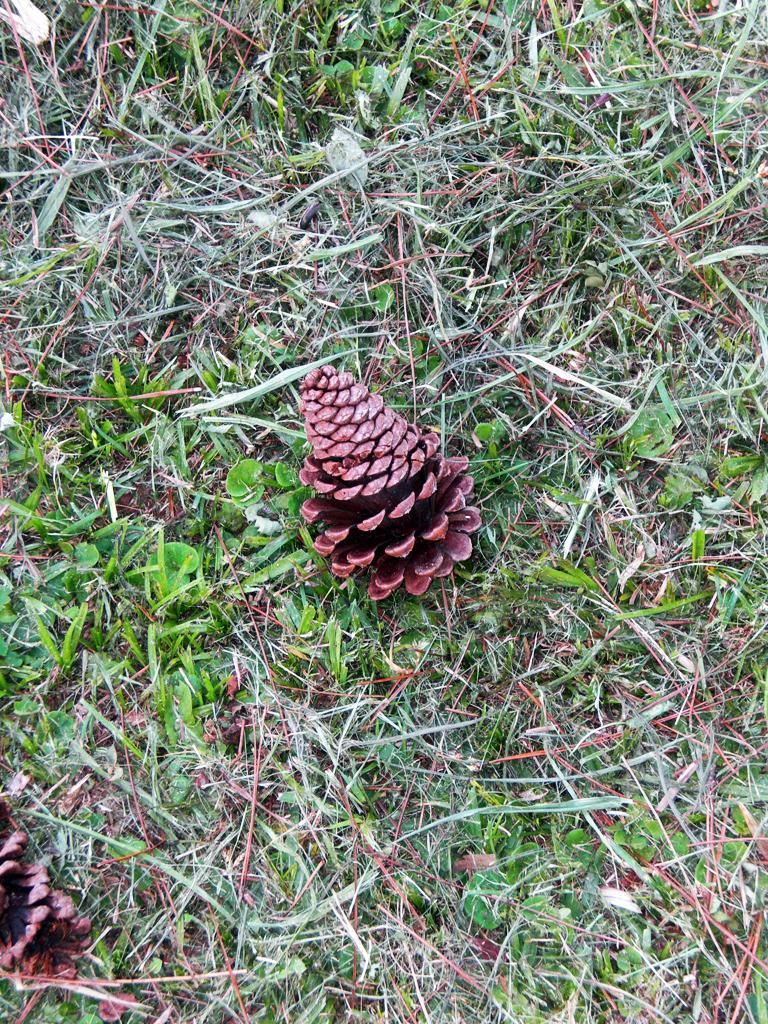What type of fruits can be seen on the grass in the image? There are pine fruits on the grass in the image. What other elements are present in the image besides the pine fruits? There are plants in the image. Can you see any animals interacting with the pine fruits in the image? There is no animal present in the image, so it cannot be determined if any animals are interacting with the pine fruits. 